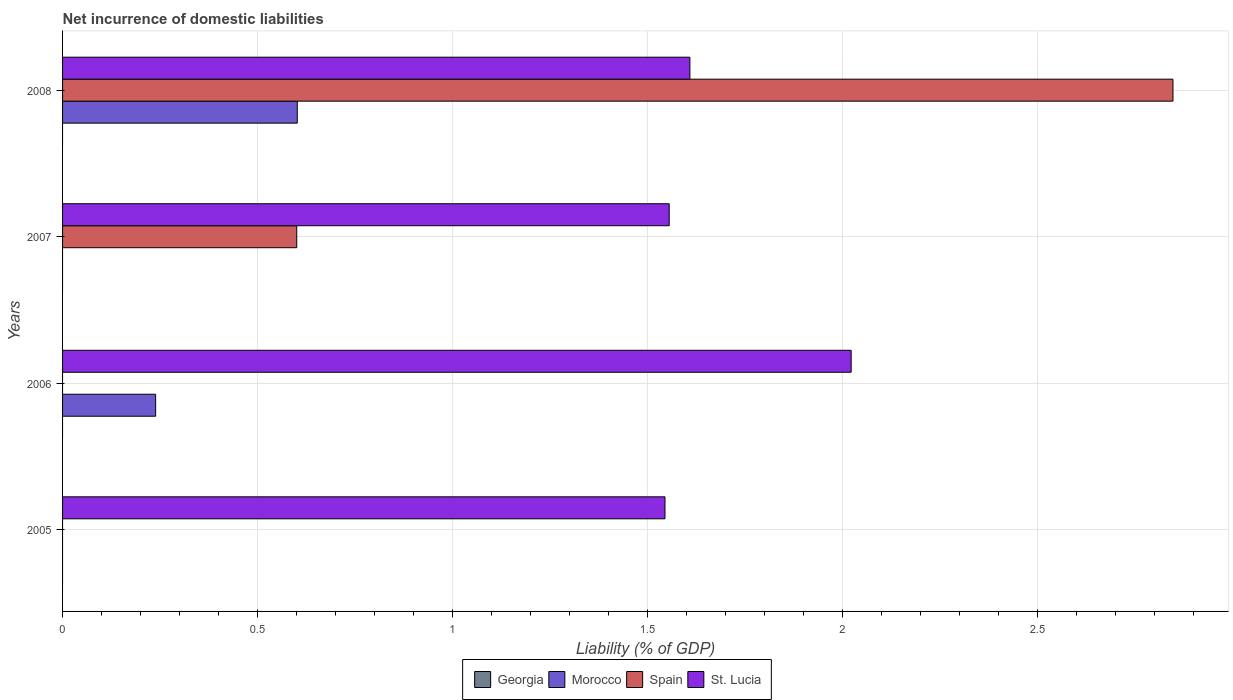Are the number of bars on each tick of the Y-axis equal?
Make the answer very short. No. How many bars are there on the 3rd tick from the top?
Give a very brief answer. 2. What is the label of the 2nd group of bars from the top?
Provide a succinct answer. 2007. What is the net incurrence of domestic liabilities in St. Lucia in 2007?
Make the answer very short. 1.56. Across all years, what is the maximum net incurrence of domestic liabilities in Spain?
Keep it short and to the point. 2.85. Across all years, what is the minimum net incurrence of domestic liabilities in Georgia?
Provide a short and direct response. 0. What is the total net incurrence of domestic liabilities in Spain in the graph?
Your answer should be compact. 3.45. What is the difference between the net incurrence of domestic liabilities in St. Lucia in 2005 and that in 2006?
Give a very brief answer. -0.48. What is the difference between the net incurrence of domestic liabilities in St. Lucia in 2006 and the net incurrence of domestic liabilities in Spain in 2008?
Provide a succinct answer. -0.83. What is the average net incurrence of domestic liabilities in Morocco per year?
Provide a succinct answer. 0.21. In the year 2006, what is the difference between the net incurrence of domestic liabilities in Morocco and net incurrence of domestic liabilities in St. Lucia?
Provide a short and direct response. -1.78. What is the ratio of the net incurrence of domestic liabilities in Spain in 2007 to that in 2008?
Make the answer very short. 0.21. Is the difference between the net incurrence of domestic liabilities in Morocco in 2006 and 2008 greater than the difference between the net incurrence of domestic liabilities in St. Lucia in 2006 and 2008?
Provide a short and direct response. No. What is the difference between the highest and the second highest net incurrence of domestic liabilities in St. Lucia?
Your answer should be very brief. 0.41. What is the difference between the highest and the lowest net incurrence of domestic liabilities in Spain?
Make the answer very short. 2.85. In how many years, is the net incurrence of domestic liabilities in St. Lucia greater than the average net incurrence of domestic liabilities in St. Lucia taken over all years?
Offer a terse response. 1. Is the sum of the net incurrence of domestic liabilities in St. Lucia in 2006 and 2008 greater than the maximum net incurrence of domestic liabilities in Morocco across all years?
Provide a short and direct response. Yes. Is it the case that in every year, the sum of the net incurrence of domestic liabilities in Spain and net incurrence of domestic liabilities in Georgia is greater than the sum of net incurrence of domestic liabilities in Morocco and net incurrence of domestic liabilities in St. Lucia?
Give a very brief answer. No. Is it the case that in every year, the sum of the net incurrence of domestic liabilities in Morocco and net incurrence of domestic liabilities in Georgia is greater than the net incurrence of domestic liabilities in St. Lucia?
Make the answer very short. No. How many bars are there?
Offer a very short reply. 8. How many years are there in the graph?
Your answer should be very brief. 4. What is the difference between two consecutive major ticks on the X-axis?
Offer a very short reply. 0.5. Where does the legend appear in the graph?
Your response must be concise. Bottom center. How many legend labels are there?
Offer a terse response. 4. What is the title of the graph?
Provide a succinct answer. Net incurrence of domestic liabilities. What is the label or title of the X-axis?
Your answer should be compact. Liability (% of GDP). What is the label or title of the Y-axis?
Keep it short and to the point. Years. What is the Liability (% of GDP) in St. Lucia in 2005?
Keep it short and to the point. 1.55. What is the Liability (% of GDP) in Georgia in 2006?
Offer a very short reply. 0. What is the Liability (% of GDP) in Morocco in 2006?
Offer a very short reply. 0.24. What is the Liability (% of GDP) of Spain in 2006?
Give a very brief answer. 0. What is the Liability (% of GDP) in St. Lucia in 2006?
Give a very brief answer. 2.02. What is the Liability (% of GDP) of Spain in 2007?
Offer a very short reply. 0.6. What is the Liability (% of GDP) of St. Lucia in 2007?
Provide a short and direct response. 1.56. What is the Liability (% of GDP) in Georgia in 2008?
Your answer should be compact. 0. What is the Liability (% of GDP) in Morocco in 2008?
Your response must be concise. 0.6. What is the Liability (% of GDP) of Spain in 2008?
Provide a short and direct response. 2.85. What is the Liability (% of GDP) of St. Lucia in 2008?
Your answer should be compact. 1.61. Across all years, what is the maximum Liability (% of GDP) in Morocco?
Your answer should be compact. 0.6. Across all years, what is the maximum Liability (% of GDP) in Spain?
Provide a succinct answer. 2.85. Across all years, what is the maximum Liability (% of GDP) in St. Lucia?
Provide a succinct answer. 2.02. Across all years, what is the minimum Liability (% of GDP) of St. Lucia?
Provide a short and direct response. 1.55. What is the total Liability (% of GDP) of Morocco in the graph?
Ensure brevity in your answer.  0.84. What is the total Liability (% of GDP) in Spain in the graph?
Keep it short and to the point. 3.45. What is the total Liability (% of GDP) of St. Lucia in the graph?
Make the answer very short. 6.73. What is the difference between the Liability (% of GDP) of St. Lucia in 2005 and that in 2006?
Provide a succinct answer. -0.48. What is the difference between the Liability (% of GDP) in St. Lucia in 2005 and that in 2007?
Give a very brief answer. -0.01. What is the difference between the Liability (% of GDP) in St. Lucia in 2005 and that in 2008?
Provide a succinct answer. -0.06. What is the difference between the Liability (% of GDP) in St. Lucia in 2006 and that in 2007?
Your response must be concise. 0.47. What is the difference between the Liability (% of GDP) of Morocco in 2006 and that in 2008?
Offer a very short reply. -0.36. What is the difference between the Liability (% of GDP) of St. Lucia in 2006 and that in 2008?
Offer a very short reply. 0.41. What is the difference between the Liability (% of GDP) of Spain in 2007 and that in 2008?
Ensure brevity in your answer.  -2.25. What is the difference between the Liability (% of GDP) in St. Lucia in 2007 and that in 2008?
Make the answer very short. -0.05. What is the difference between the Liability (% of GDP) in Morocco in 2006 and the Liability (% of GDP) in Spain in 2007?
Give a very brief answer. -0.36. What is the difference between the Liability (% of GDP) of Morocco in 2006 and the Liability (% of GDP) of St. Lucia in 2007?
Your response must be concise. -1.32. What is the difference between the Liability (% of GDP) in Morocco in 2006 and the Liability (% of GDP) in Spain in 2008?
Offer a terse response. -2.61. What is the difference between the Liability (% of GDP) in Morocco in 2006 and the Liability (% of GDP) in St. Lucia in 2008?
Keep it short and to the point. -1.37. What is the difference between the Liability (% of GDP) of Spain in 2007 and the Liability (% of GDP) of St. Lucia in 2008?
Ensure brevity in your answer.  -1.01. What is the average Liability (% of GDP) of Georgia per year?
Give a very brief answer. 0. What is the average Liability (% of GDP) in Morocco per year?
Keep it short and to the point. 0.21. What is the average Liability (% of GDP) of Spain per year?
Ensure brevity in your answer.  0.86. What is the average Liability (% of GDP) of St. Lucia per year?
Give a very brief answer. 1.68. In the year 2006, what is the difference between the Liability (% of GDP) of Morocco and Liability (% of GDP) of St. Lucia?
Your answer should be compact. -1.78. In the year 2007, what is the difference between the Liability (% of GDP) in Spain and Liability (% of GDP) in St. Lucia?
Give a very brief answer. -0.96. In the year 2008, what is the difference between the Liability (% of GDP) of Morocco and Liability (% of GDP) of Spain?
Offer a terse response. -2.25. In the year 2008, what is the difference between the Liability (% of GDP) of Morocco and Liability (% of GDP) of St. Lucia?
Provide a short and direct response. -1.01. In the year 2008, what is the difference between the Liability (% of GDP) of Spain and Liability (% of GDP) of St. Lucia?
Your answer should be compact. 1.24. What is the ratio of the Liability (% of GDP) in St. Lucia in 2005 to that in 2006?
Give a very brief answer. 0.76. What is the ratio of the Liability (% of GDP) of St. Lucia in 2005 to that in 2008?
Give a very brief answer. 0.96. What is the ratio of the Liability (% of GDP) of St. Lucia in 2006 to that in 2007?
Make the answer very short. 1.3. What is the ratio of the Liability (% of GDP) in Morocco in 2006 to that in 2008?
Ensure brevity in your answer.  0.4. What is the ratio of the Liability (% of GDP) of St. Lucia in 2006 to that in 2008?
Offer a very short reply. 1.26. What is the ratio of the Liability (% of GDP) in Spain in 2007 to that in 2008?
Your answer should be very brief. 0.21. What is the ratio of the Liability (% of GDP) of St. Lucia in 2007 to that in 2008?
Your response must be concise. 0.97. What is the difference between the highest and the second highest Liability (% of GDP) of St. Lucia?
Ensure brevity in your answer.  0.41. What is the difference between the highest and the lowest Liability (% of GDP) in Morocco?
Provide a short and direct response. 0.6. What is the difference between the highest and the lowest Liability (% of GDP) in Spain?
Provide a succinct answer. 2.85. What is the difference between the highest and the lowest Liability (% of GDP) in St. Lucia?
Provide a succinct answer. 0.48. 